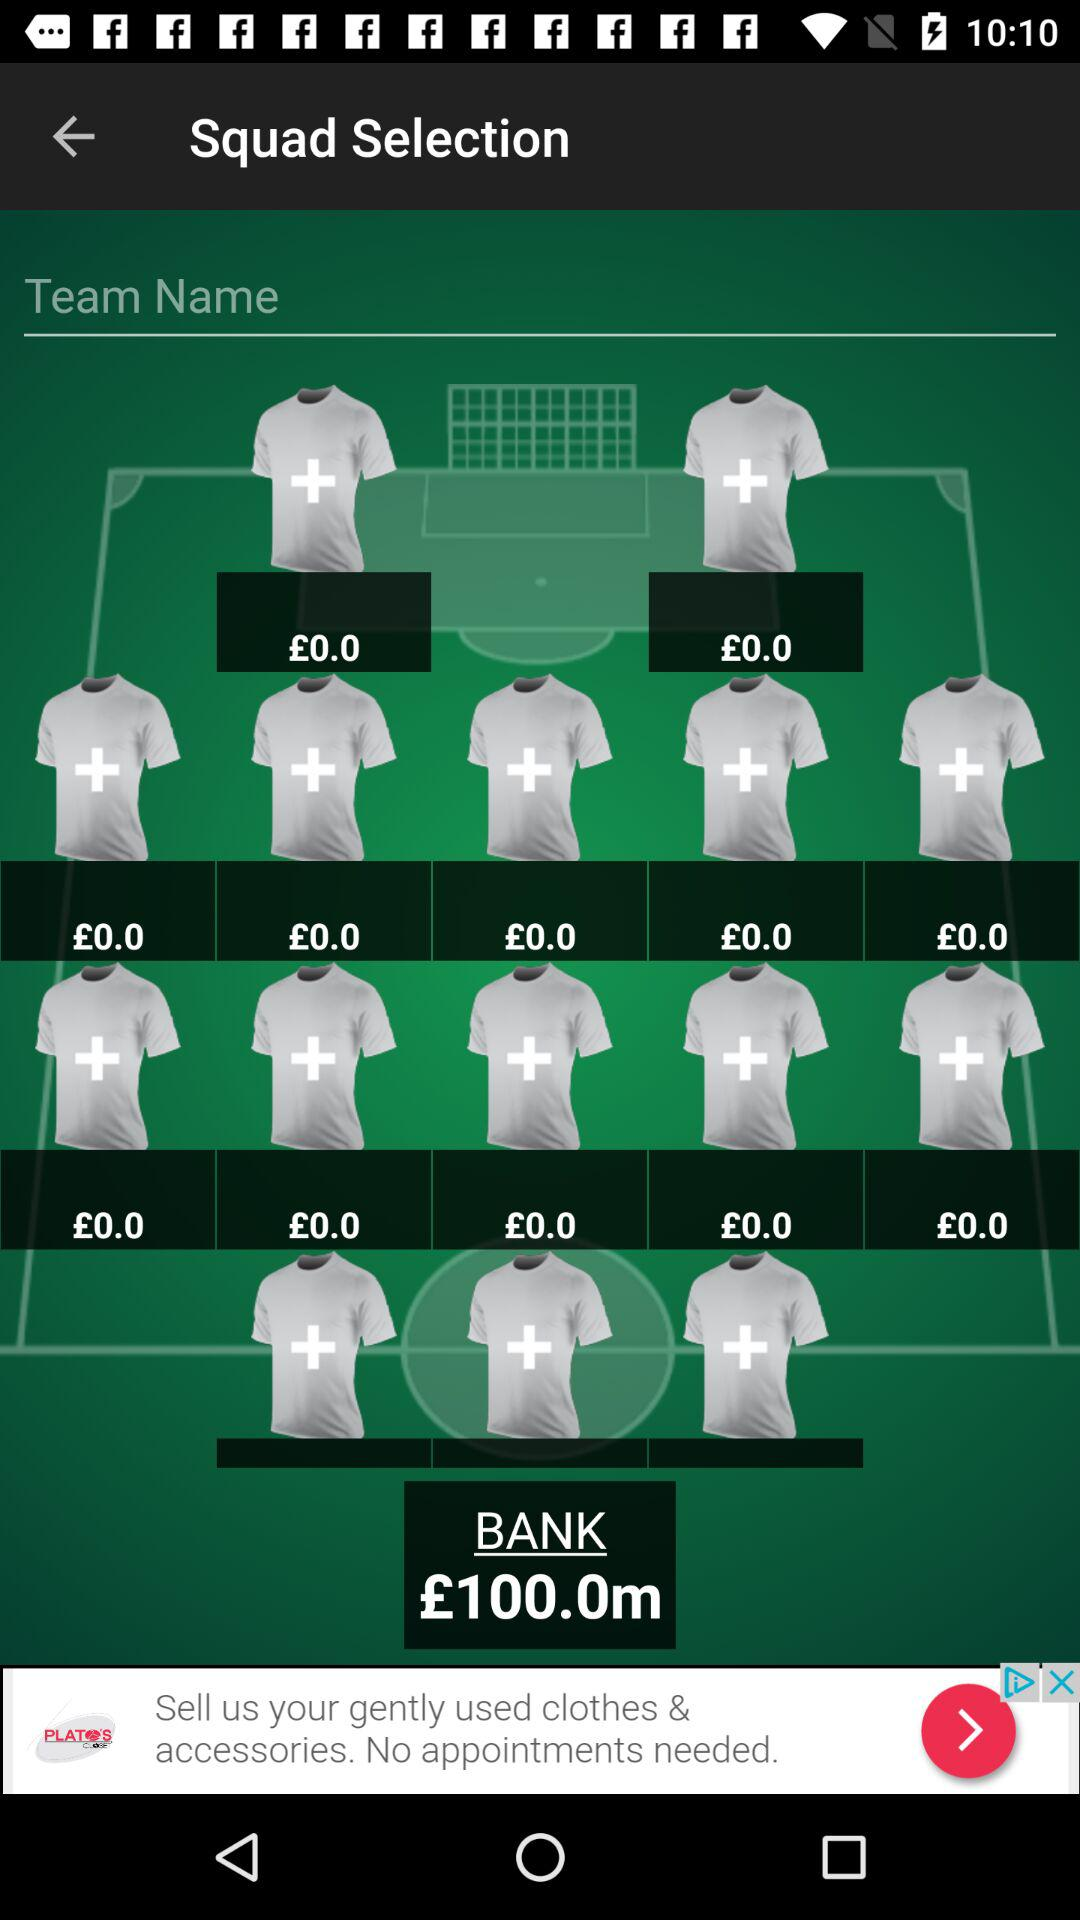How many more shirts are in the second row than the first row?
Answer the question using a single word or phrase. 3 